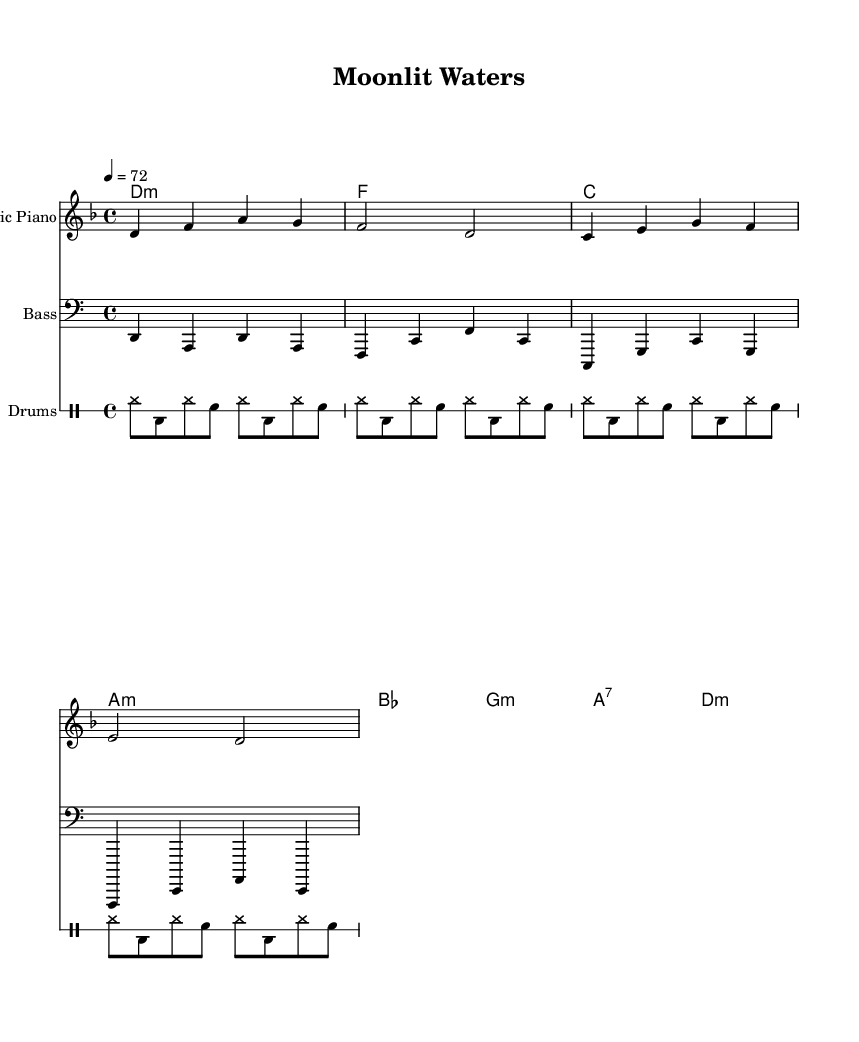What is the key signature of this music? The key signature is represented by the "d minor" in the global setting. D minor has one flat.
Answer: d minor What is the time signature of this music? The time signature is indicated by "4/4" in the global setting, which means there are four beats in each measure and the quarter note gets one beat.
Answer: 4/4 What is the tempo marking for this piece? The tempo marking is given as "4 = 72", meaning that there are 72 quarter note beats per minute in the tempo.
Answer: 72 How many measures does the melody have? By counting the melody notation, there are a total of 4 measures present in the melody section.
Answer: 4 measures What type of piano is indicated for playing the melody? The instrument name for the melody staff is specified as "Electric Piano" in the score.
Answer: Electric Piano What is the bass clef's notation for the first note? The bass line notation starts with the note "d", which is the first note in the bass clef.
Answer: d Which chord represents the second measure? The second measure of the harmonies indicates the chord "f", which is in the second position of the chord sequence.
Answer: f 